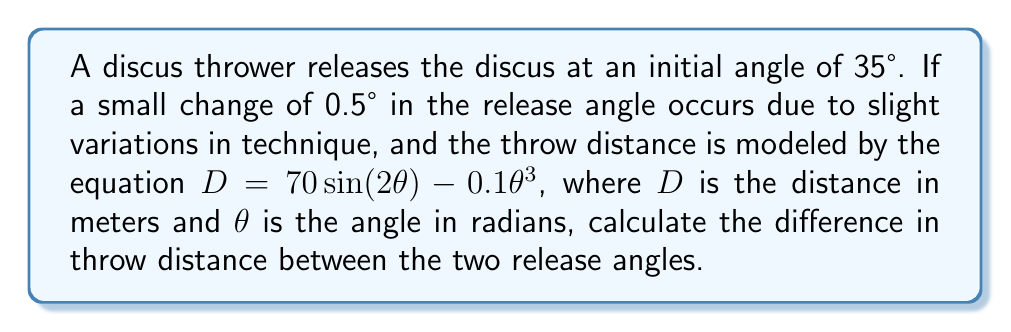Provide a solution to this math problem. 1. Convert the angles from degrees to radians:
   $\theta_1 = 35° \times \frac{\pi}{180°} = 0.6109$ radians
   $\theta_2 = 35.5° \times \frac{\pi}{180°} = 0.6196$ radians

2. Calculate the distance for the initial angle ($\theta_1$):
   $D_1 = 70 \sin(2 \times 0.6109) - 0.1(0.6109)^3$
   $D_1 = 70 \sin(1.2218) - 0.1(0.2280)$
   $D_1 = 70 \times 0.9399 - 0.0228$
   $D_1 = 65.7702$ meters

3. Calculate the distance for the new angle ($\theta_2$):
   $D_2 = 70 \sin(2 \times 0.6196) - 0.1(0.6196)^3$
   $D_2 = 70 \sin(1.2392) - 0.1(0.2377)$
   $D_2 = 70 \times 0.9451 - 0.0238$
   $D_2 = 66.1332$ meters

4. Calculate the difference in throw distance:
   $\Delta D = D_2 - D_1 = 66.1332 - 65.7702 = 0.3630$ meters

This demonstrates the butterfly effect, where a small change in the initial conditions (release angle) leads to a noticeable difference in the outcome (throw distance).
Answer: 0.3630 meters 